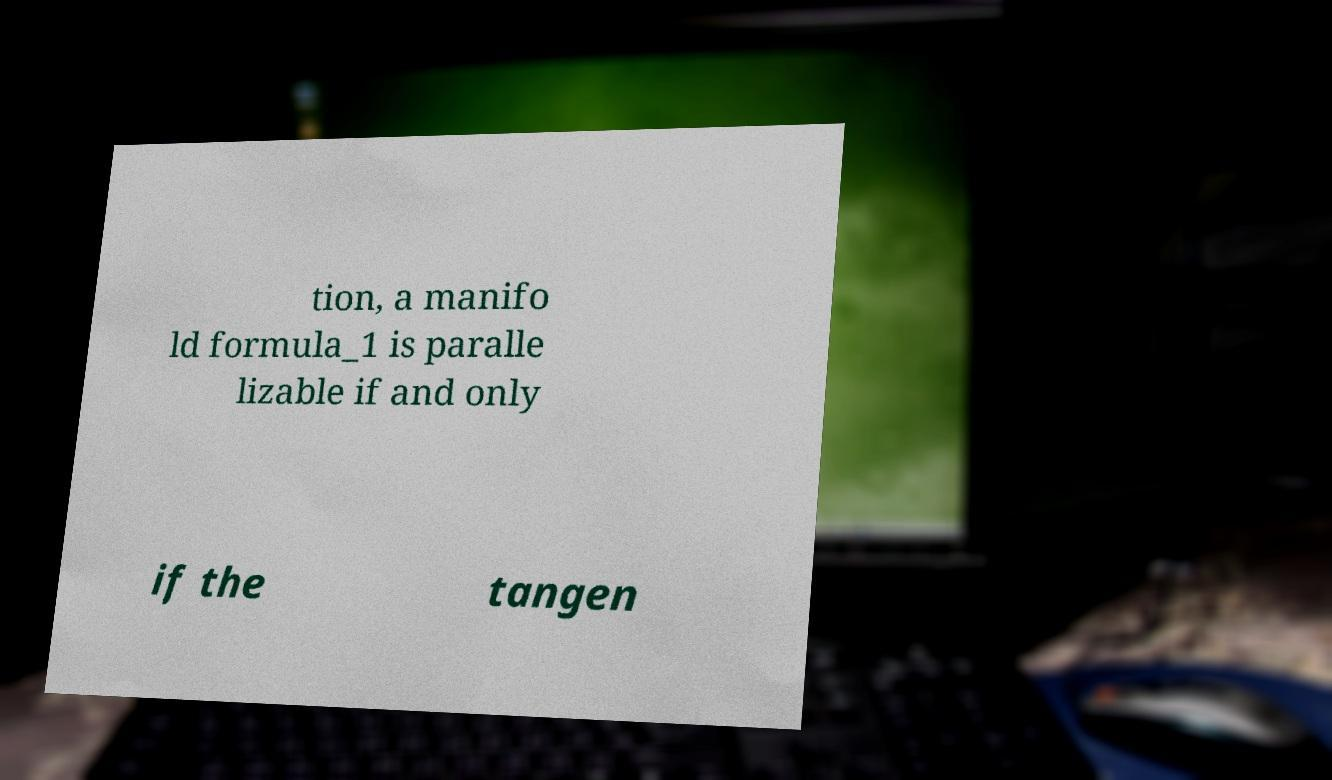Please identify and transcribe the text found in this image. tion, a manifo ld formula_1 is paralle lizable if and only if the tangen 